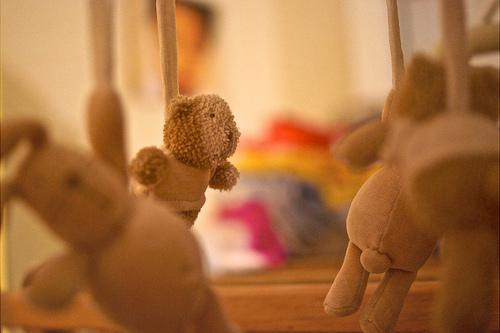Question: what color are the stuffed animals?
Choices:
A. Brown.
B. Black.
C. White.
D. Red.
Answer with the letter. Answer: A Question: what is the subject of the photo?
Choices:
A. People.
B. Stuffed animals.
C. Animals.
D. Houses.
Answer with the letter. Answer: B 